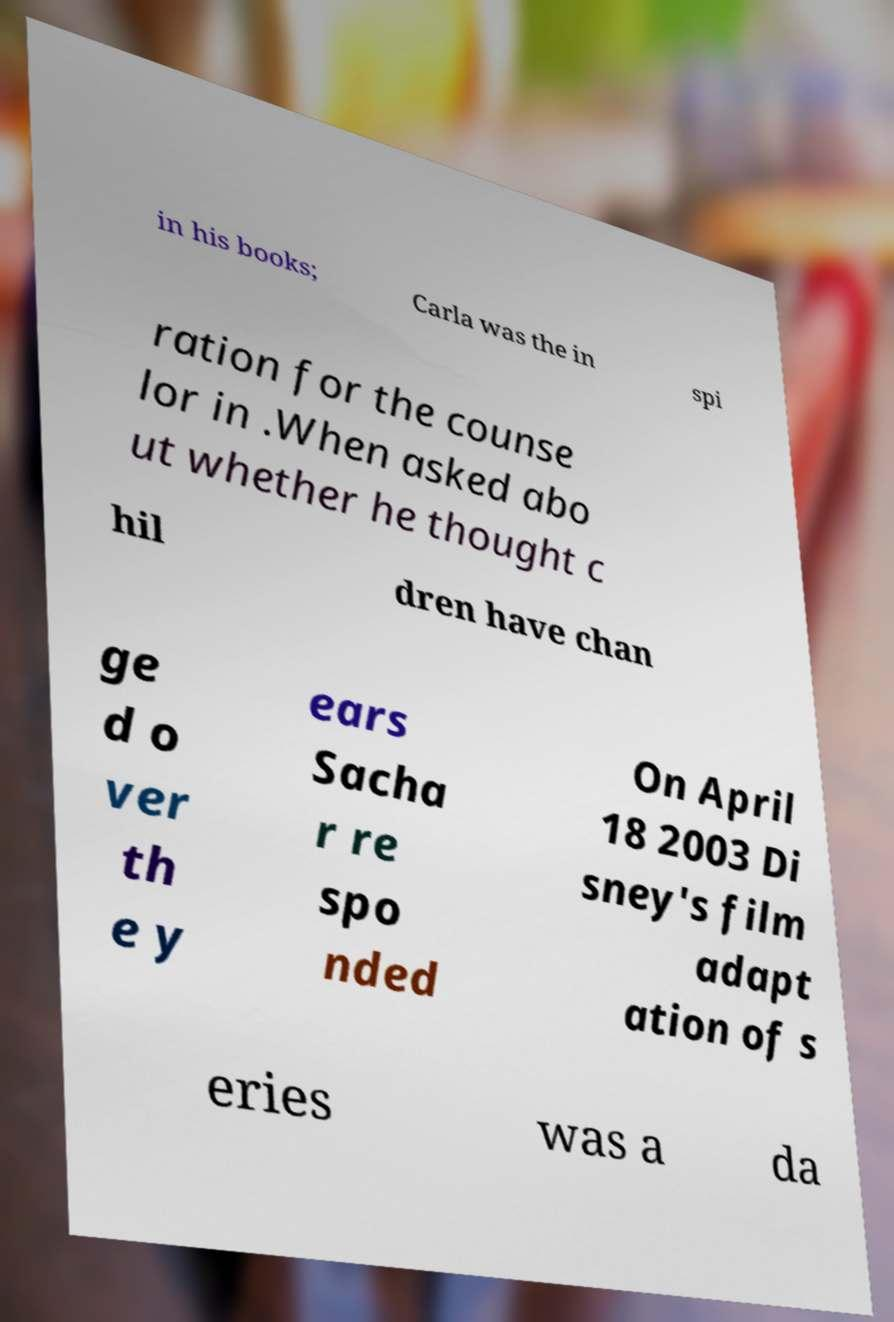Could you assist in decoding the text presented in this image and type it out clearly? in his books; Carla was the in spi ration for the counse lor in .When asked abo ut whether he thought c hil dren have chan ge d o ver th e y ears Sacha r re spo nded On April 18 2003 Di sney's film adapt ation of s eries was a da 